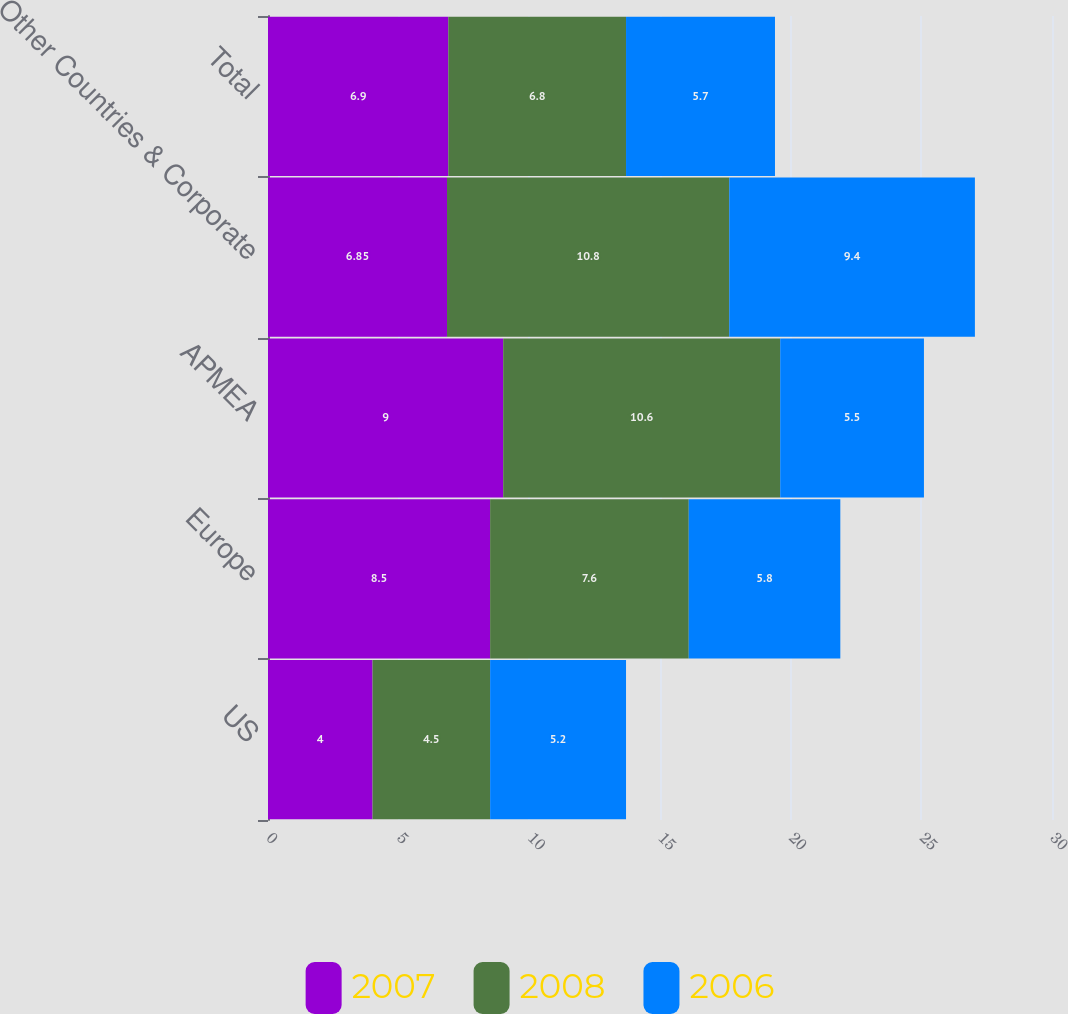Convert chart to OTSL. <chart><loc_0><loc_0><loc_500><loc_500><stacked_bar_chart><ecel><fcel>US<fcel>Europe<fcel>APMEA<fcel>Other Countries & Corporate<fcel>Total<nl><fcel>2007<fcel>4<fcel>8.5<fcel>9<fcel>6.85<fcel>6.9<nl><fcel>2008<fcel>4.5<fcel>7.6<fcel>10.6<fcel>10.8<fcel>6.8<nl><fcel>2006<fcel>5.2<fcel>5.8<fcel>5.5<fcel>9.4<fcel>5.7<nl></chart> 